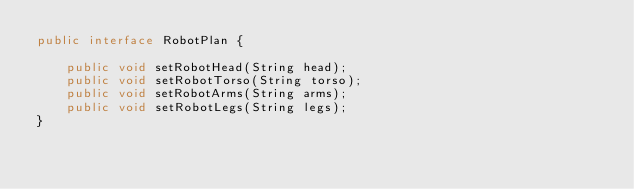<code> <loc_0><loc_0><loc_500><loc_500><_Java_>public interface RobotPlan {

    public void setRobotHead(String head);
    public void setRobotTorso(String torso);
    public void setRobotArms(String arms);
    public void setRobotLegs(String legs);
}</code> 